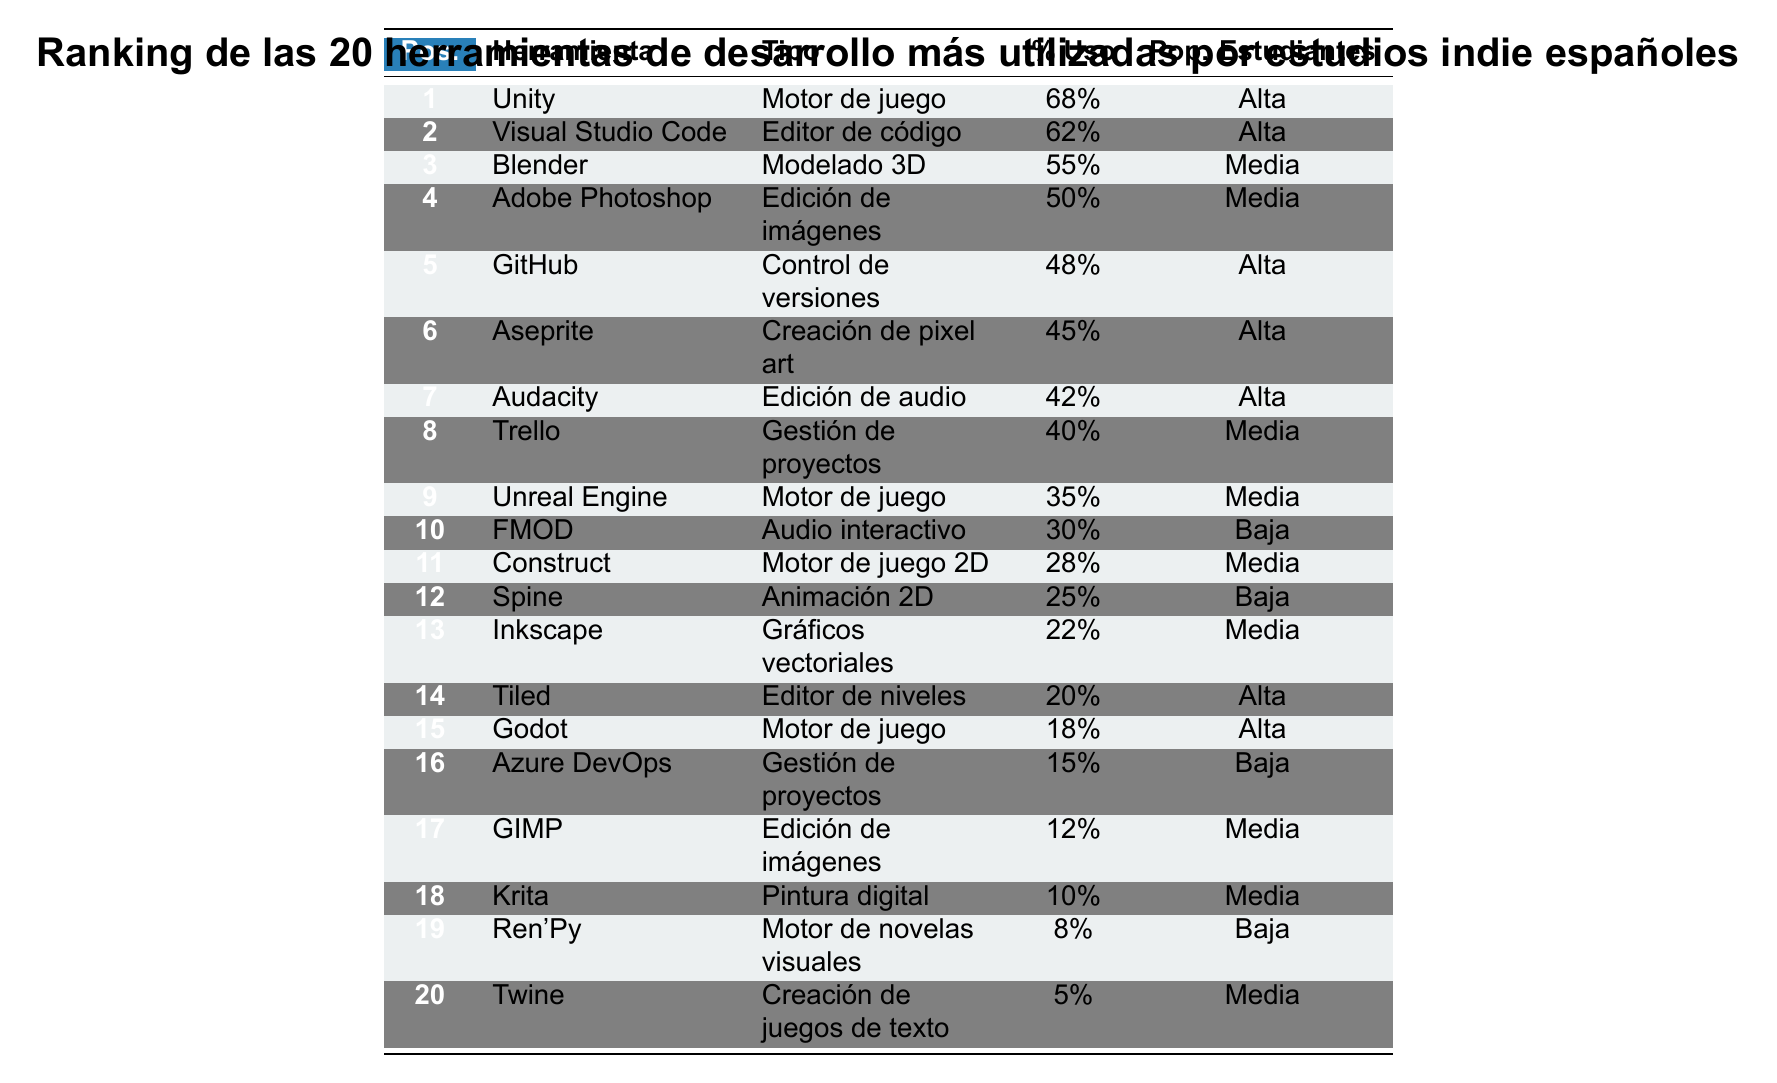¿Cuál es la herramienta más utilizada por los estudios indie españoles? La herramienta más utilizada es Unity, que ocupa la primera posición en el ranking.
Answer: Unity ¿Qué porcentaje de uso tiene Visual Studio Code? Visual Studio Code tiene un porcentaje de uso del 62%, como se indica en la tabla.
Answer: 62% ¿Hay más herramientas de edición de imágenes que de motores de juego en la lista? Hay 4 herramientas de edición de imágenes (Adobe Photoshop, GIMP, Krita) y 6 motores de juego (Unity, Unreal Engine, Construct, Godot, entre otros), por lo que hay más motores de juego.
Answer: No ¿Cuántas herramientas tienen una popularidad alta entre los estudiantes? Se puede observar que hay 8 herramientas que tienen una popularidad alta entre los estudiantes: Unity, Visual Studio Code, GitHub, Aseprite, Audacity, Tiled, Godot y Trello.
Answer: 8 ¿Cuál es la herramienta con el menor porcentaje de uso y su tipo? La herramienta con el menor porcentaje de uso es Twine, con un 5%, y su tipo es "Creación de juegos de texto".
Answer: Twine, Creación de juegos de texto Si sumamos los porcentajes de uso de las cinco herramientas más populares, ¿cuál sería el total? Sumando los porcentajes: 68% (Unity) + 62% (Visual Studio Code) + 55% (Blender) + 50% (Adobe Photoshop) + 48% (GitHub) obtenemos un total de 283%.
Answer: 283% ¿Cuántas herramientas de audio tienen un porcentaje de uso mayor al 40%? Hay dos herramientas de audio que tienen un porcentaje de uso mayor al 40%: Audacity (42%) y FMOD (30%).
Answer: 1 Si consideramos solo las herramientas con popularidad alta entre estudiantes, ¿cuál es la herramienta con menor porcentaje de uso? La herramienta con menor porcentaje de uso entre las de popularidad alta es Godot, que tiene un 18% de uso, mientras que otras tienen porcentajes más altos.
Answer: Godot ¿Hay alguna herramienta de gestión de proyectos que tenga una popularidad alta entre los estudiantes? La única herramienta de gestión de proyectos en la lista que tiene popularidad alta es Trello, que se encuentra en la posición 8 con un 40% de uso.
Answer: Sí, Trello ¿Cuál es la diferencia de porcentaje de uso entre la herramienta más utilizada y la más utilizada para la creación de juegos de texto? La diferencia es 68% (Unity) - 5% (Twine) = 63%.
Answer: 63% 